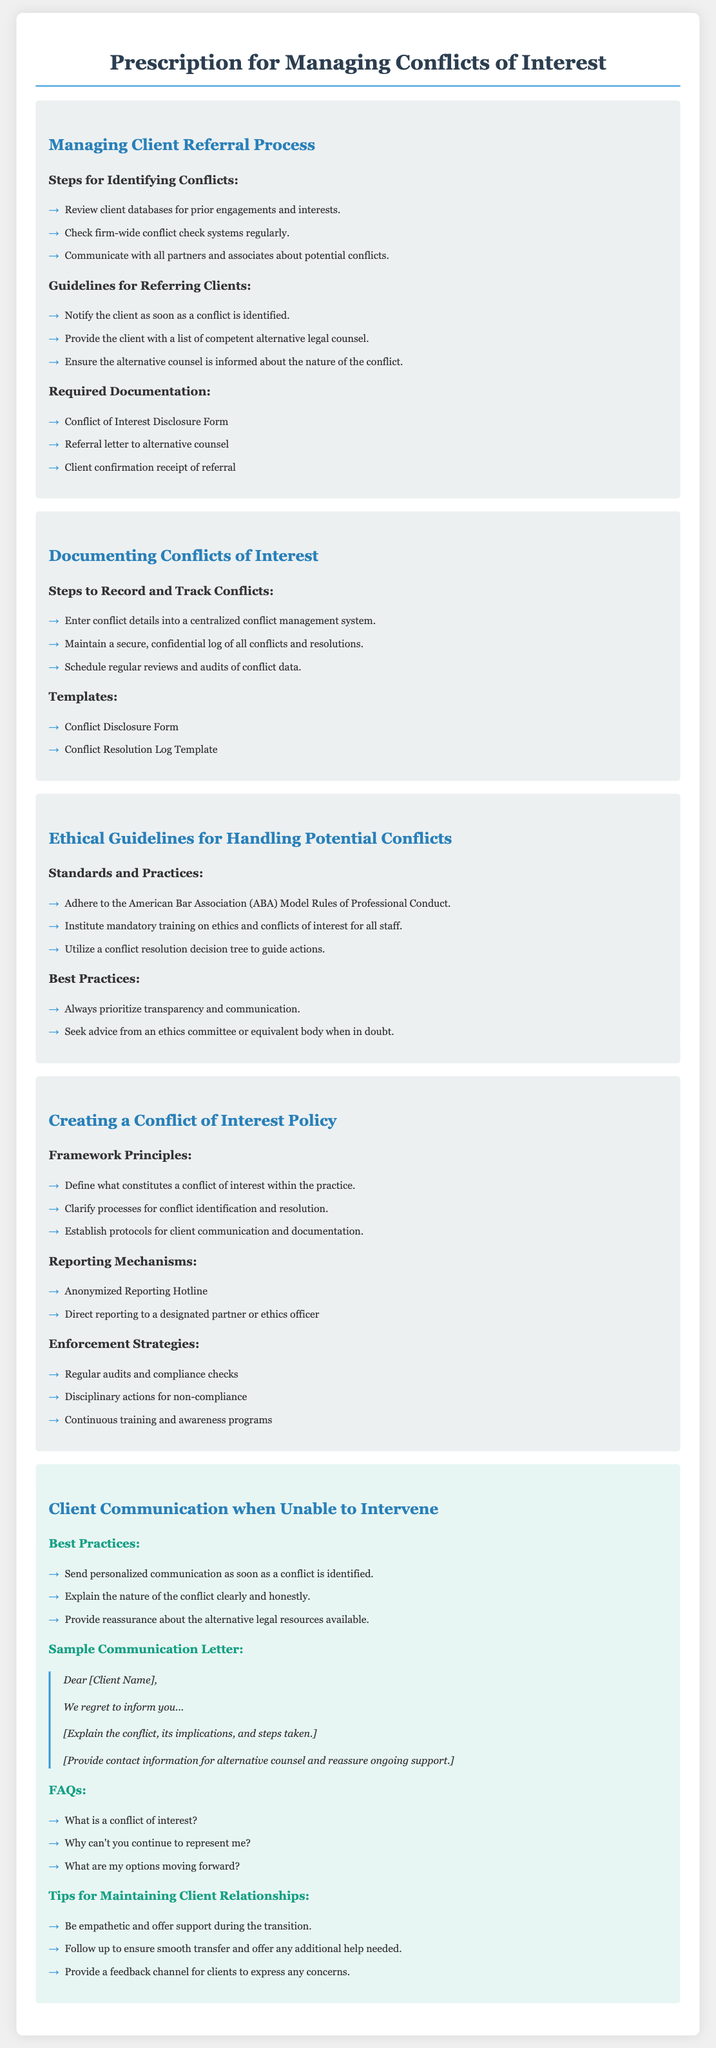What are the steps for identifying conflicts? The document lists steps for identifying conflicts including reviewing client databases, checking conflict check systems, and communicating with partners.
Answer: Review client databases for prior engagements and interests What is a required document for client referral? Among the documents needed for referring clients, one is specified as mandatory in the document.
Answer: Referral letter to alternative counsel What is the purpose of a Conflict Disclosure Form? The document states this form is essential for documenting conflicts of interest.
Answer: To disclose conflict of interest What should you prioritize according to best practices? The document emphasizes a practice that is critical when handling conflicts, focusing on a specific attitude.
Answer: Transparency and communication What is a reporting mechanism suggested in the policy creation section? The document outlines a specific method for reporting conflicts that provides anonymity to the reporter.
Answer: Anonymized Reporting Hotline How should clients be informed of conflicts? The document outlines a process for client communication when a conflict arises, which includes providing certain information.
Answer: Personalized communication What type of training is recommended in the ethical guidelines? The document recommends a specific type of training for staff in relation to ethical practices.
Answer: Mandatory training on ethics and conflicts of interest What should be maintained according to conflict documentation? The document emphasizes the need for a certain type of log related to conflicts.
Answer: A secure, confidential log of all conflicts and resolutions 